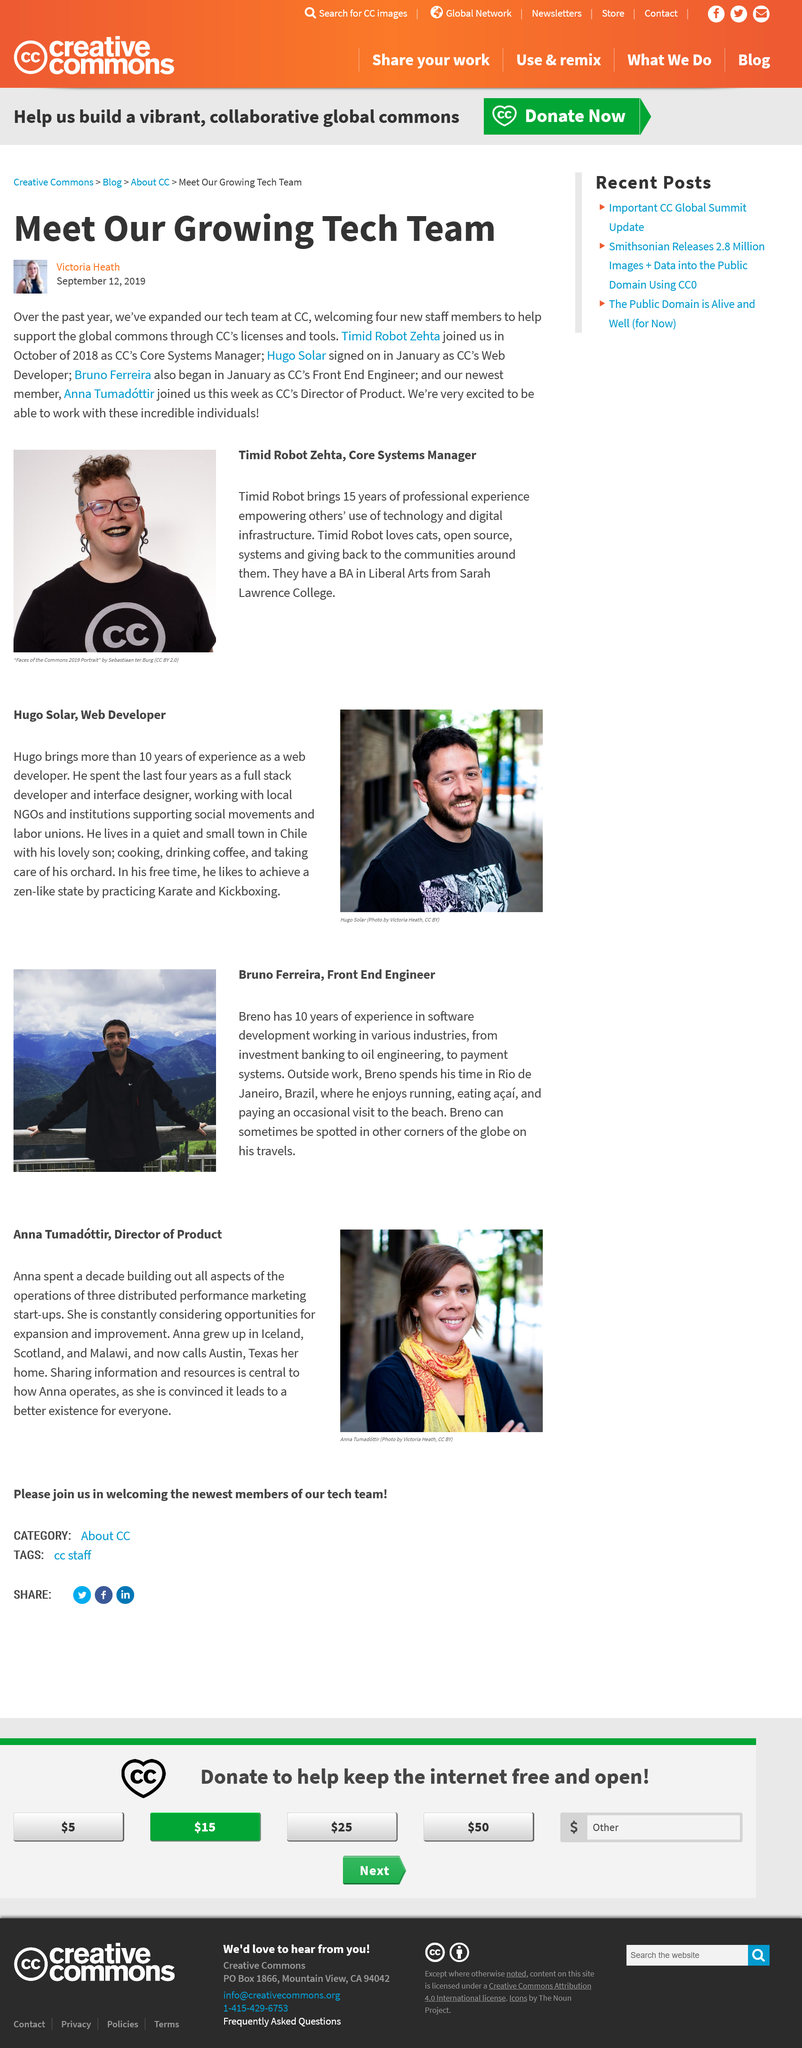List a handful of essential elements in this visual. Breno enjoys eating acai. Anna grew up in three different countries: Scotland, Iceland, and Malawi. The man in the photo is named Hugo Solar. Timid Robot loves cats, and it is known. Bruo Ferreira is a Front End Engineer. 